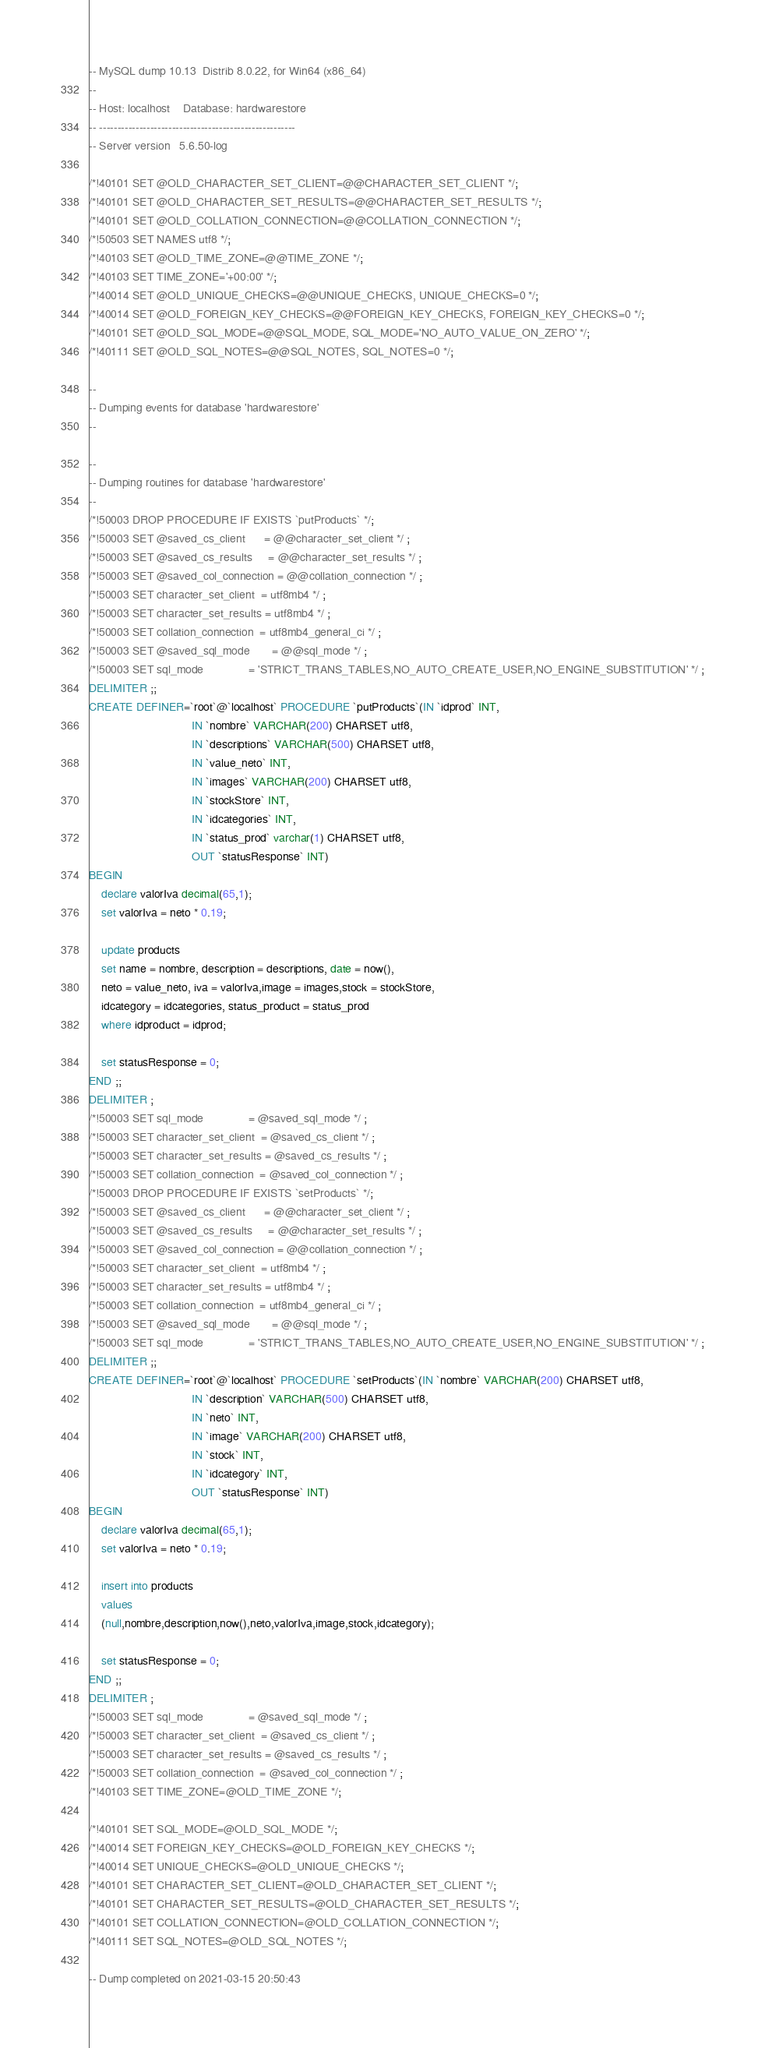Convert code to text. <code><loc_0><loc_0><loc_500><loc_500><_SQL_>-- MySQL dump 10.13  Distrib 8.0.22, for Win64 (x86_64)
--
-- Host: localhost    Database: hardwarestore
-- ------------------------------------------------------
-- Server version	5.6.50-log

/*!40101 SET @OLD_CHARACTER_SET_CLIENT=@@CHARACTER_SET_CLIENT */;
/*!40101 SET @OLD_CHARACTER_SET_RESULTS=@@CHARACTER_SET_RESULTS */;
/*!40101 SET @OLD_COLLATION_CONNECTION=@@COLLATION_CONNECTION */;
/*!50503 SET NAMES utf8 */;
/*!40103 SET @OLD_TIME_ZONE=@@TIME_ZONE */;
/*!40103 SET TIME_ZONE='+00:00' */;
/*!40014 SET @OLD_UNIQUE_CHECKS=@@UNIQUE_CHECKS, UNIQUE_CHECKS=0 */;
/*!40014 SET @OLD_FOREIGN_KEY_CHECKS=@@FOREIGN_KEY_CHECKS, FOREIGN_KEY_CHECKS=0 */;
/*!40101 SET @OLD_SQL_MODE=@@SQL_MODE, SQL_MODE='NO_AUTO_VALUE_ON_ZERO' */;
/*!40111 SET @OLD_SQL_NOTES=@@SQL_NOTES, SQL_NOTES=0 */;

--
-- Dumping events for database 'hardwarestore'
--

--
-- Dumping routines for database 'hardwarestore'
--
/*!50003 DROP PROCEDURE IF EXISTS `putProducts` */;
/*!50003 SET @saved_cs_client      = @@character_set_client */ ;
/*!50003 SET @saved_cs_results     = @@character_set_results */ ;
/*!50003 SET @saved_col_connection = @@collation_connection */ ;
/*!50003 SET character_set_client  = utf8mb4 */ ;
/*!50003 SET character_set_results = utf8mb4 */ ;
/*!50003 SET collation_connection  = utf8mb4_general_ci */ ;
/*!50003 SET @saved_sql_mode       = @@sql_mode */ ;
/*!50003 SET sql_mode              = 'STRICT_TRANS_TABLES,NO_AUTO_CREATE_USER,NO_ENGINE_SUBSTITUTION' */ ;
DELIMITER ;;
CREATE DEFINER=`root`@`localhost` PROCEDURE `putProducts`(IN `idprod` INT,
								IN `nombre` VARCHAR(200) CHARSET utf8,
								IN `descriptions` VARCHAR(500) CHARSET utf8,
								IN `value_neto` INT,
								IN `images` VARCHAR(200) CHARSET utf8,
                                IN `stockStore` INT,
                                IN `idcategories` INT,
                                IN `status_prod` varchar(1) CHARSET utf8,
                                OUT `statusResponse` INT)
BEGIN   
	declare valorIva decimal(65,1);	
    set valorIva = neto * 0.19;
    
	update products 
	set name = nombre, description = descriptions, date = now(), 
    neto = value_neto, iva = valorIva,image = images,stock = stockStore,
    idcategory = idcategories, status_product = status_prod
    where idproduct = idprod;
    
    set statusResponse = 0;
END ;;
DELIMITER ;
/*!50003 SET sql_mode              = @saved_sql_mode */ ;
/*!50003 SET character_set_client  = @saved_cs_client */ ;
/*!50003 SET character_set_results = @saved_cs_results */ ;
/*!50003 SET collation_connection  = @saved_col_connection */ ;
/*!50003 DROP PROCEDURE IF EXISTS `setProducts` */;
/*!50003 SET @saved_cs_client      = @@character_set_client */ ;
/*!50003 SET @saved_cs_results     = @@character_set_results */ ;
/*!50003 SET @saved_col_connection = @@collation_connection */ ;
/*!50003 SET character_set_client  = utf8mb4 */ ;
/*!50003 SET character_set_results = utf8mb4 */ ;
/*!50003 SET collation_connection  = utf8mb4_general_ci */ ;
/*!50003 SET @saved_sql_mode       = @@sql_mode */ ;
/*!50003 SET sql_mode              = 'STRICT_TRANS_TABLES,NO_AUTO_CREATE_USER,NO_ENGINE_SUBSTITUTION' */ ;
DELIMITER ;;
CREATE DEFINER=`root`@`localhost` PROCEDURE `setProducts`(IN `nombre` VARCHAR(200) CHARSET utf8,
								IN `description` VARCHAR(500) CHARSET utf8,
								IN `neto` INT,
								IN `image` VARCHAR(200) CHARSET utf8,
                                IN `stock` INT,
                                IN `idcategory` INT,
                                OUT `statusResponse` INT)
BEGIN   
	declare valorIva decimal(65,1);	
    set valorIva = neto * 0.19;
    
	insert into products 
	values 
	(null,nombre,description,now(),neto,valorIva,image,stock,idcategory);
    
    set statusResponse = 0;
END ;;
DELIMITER ;
/*!50003 SET sql_mode              = @saved_sql_mode */ ;
/*!50003 SET character_set_client  = @saved_cs_client */ ;
/*!50003 SET character_set_results = @saved_cs_results */ ;
/*!50003 SET collation_connection  = @saved_col_connection */ ;
/*!40103 SET TIME_ZONE=@OLD_TIME_ZONE */;

/*!40101 SET SQL_MODE=@OLD_SQL_MODE */;
/*!40014 SET FOREIGN_KEY_CHECKS=@OLD_FOREIGN_KEY_CHECKS */;
/*!40014 SET UNIQUE_CHECKS=@OLD_UNIQUE_CHECKS */;
/*!40101 SET CHARACTER_SET_CLIENT=@OLD_CHARACTER_SET_CLIENT */;
/*!40101 SET CHARACTER_SET_RESULTS=@OLD_CHARACTER_SET_RESULTS */;
/*!40101 SET COLLATION_CONNECTION=@OLD_COLLATION_CONNECTION */;
/*!40111 SET SQL_NOTES=@OLD_SQL_NOTES */;

-- Dump completed on 2021-03-15 20:50:43
</code> 